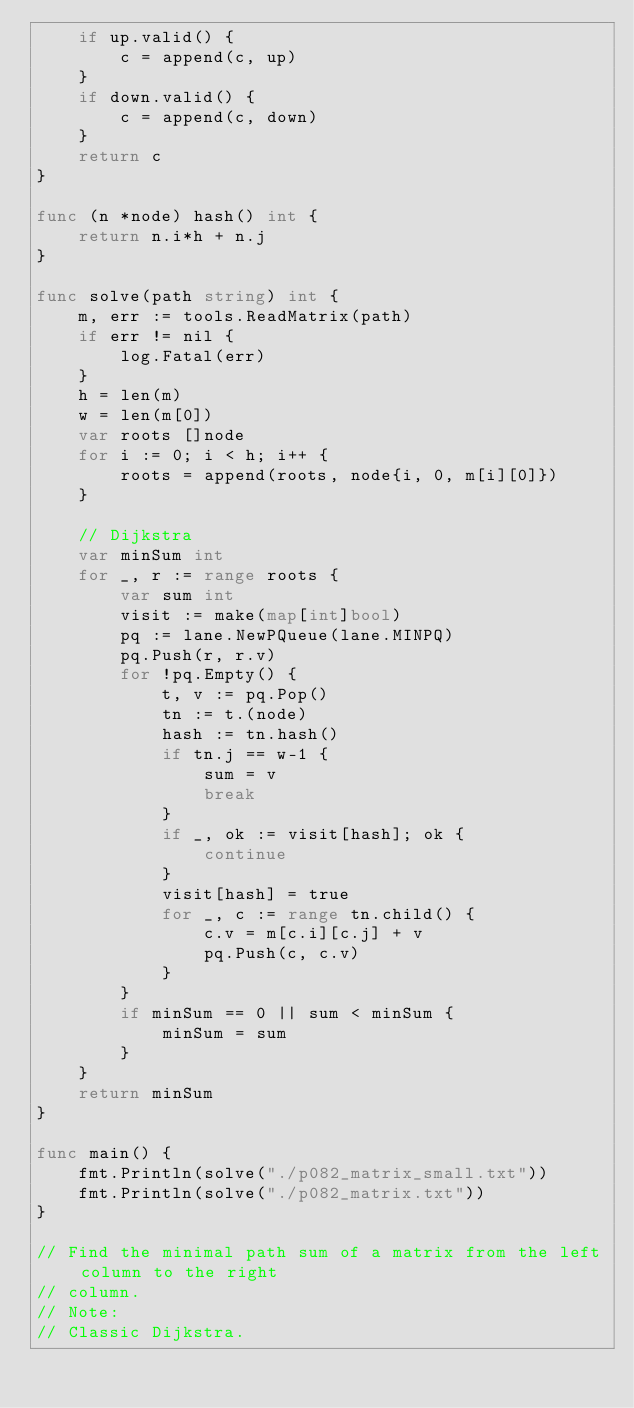<code> <loc_0><loc_0><loc_500><loc_500><_Go_>	if up.valid() {
		c = append(c, up)
	}
	if down.valid() {
		c = append(c, down)
	}
	return c
}

func (n *node) hash() int {
	return n.i*h + n.j
}

func solve(path string) int {
	m, err := tools.ReadMatrix(path)
	if err != nil {
		log.Fatal(err)
	}
	h = len(m)
	w = len(m[0])
	var roots []node
	for i := 0; i < h; i++ {
		roots = append(roots, node{i, 0, m[i][0]})
	}

	// Dijkstra
	var minSum int
	for _, r := range roots {
		var sum int
		visit := make(map[int]bool)
		pq := lane.NewPQueue(lane.MINPQ)
		pq.Push(r, r.v)
		for !pq.Empty() {
			t, v := pq.Pop()
			tn := t.(node)
			hash := tn.hash()
			if tn.j == w-1 {
				sum = v
				break
			}
			if _, ok := visit[hash]; ok {
				continue
			}
			visit[hash] = true
			for _, c := range tn.child() {
				c.v = m[c.i][c.j] + v
				pq.Push(c, c.v)
			}
		}
		if minSum == 0 || sum < minSum {
			minSum = sum
		}
	}
	return minSum
}

func main() {
	fmt.Println(solve("./p082_matrix_small.txt"))
	fmt.Println(solve("./p082_matrix.txt"))
}

// Find the minimal path sum of a matrix from the left column to the right
// column.
// Note:
// Classic Dijkstra.
</code> 